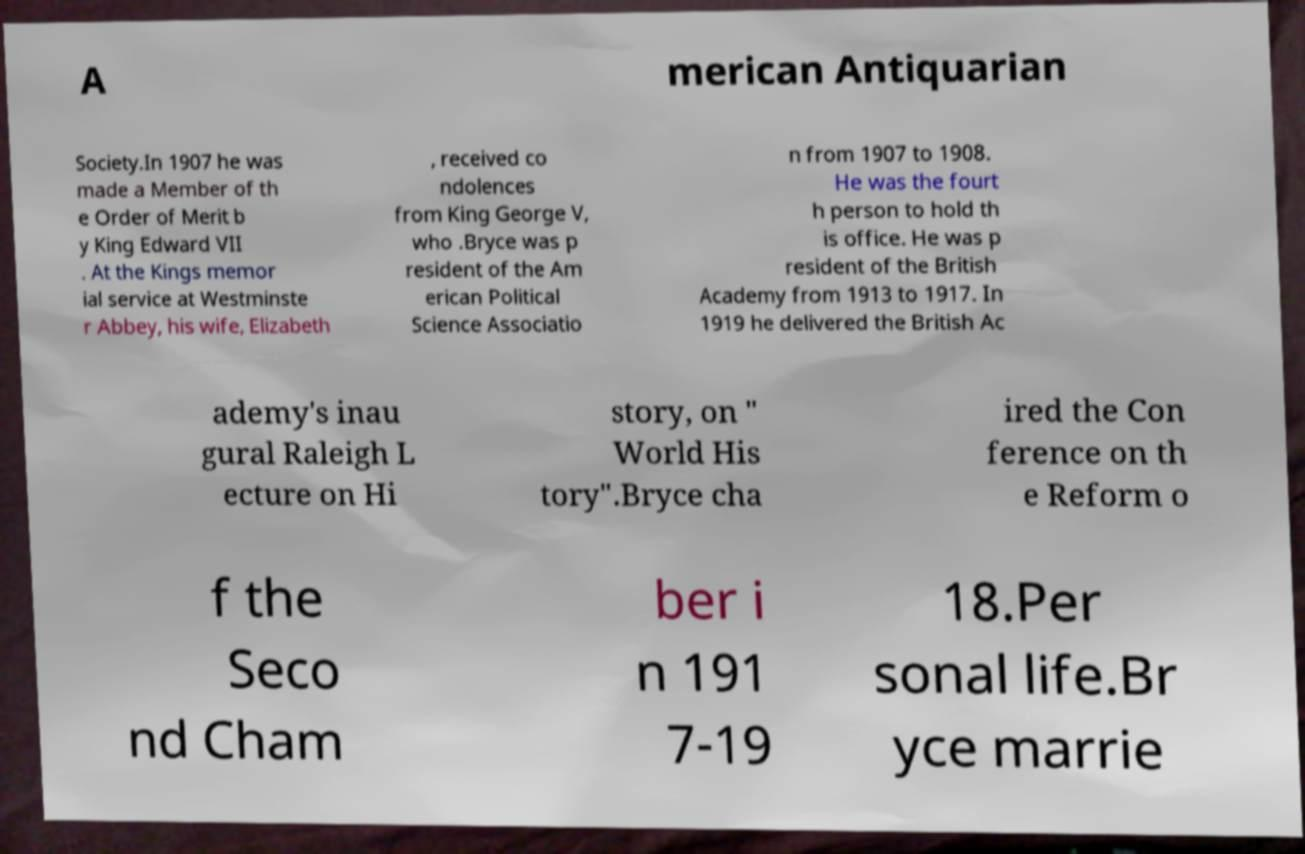Could you extract and type out the text from this image? A merican Antiquarian Society.In 1907 he was made a Member of th e Order of Merit b y King Edward VII . At the Kings memor ial service at Westminste r Abbey, his wife, Elizabeth , received co ndolences from King George V, who .Bryce was p resident of the Am erican Political Science Associatio n from 1907 to 1908. He was the fourt h person to hold th is office. He was p resident of the British Academy from 1913 to 1917. In 1919 he delivered the British Ac ademy's inau gural Raleigh L ecture on Hi story, on " World His tory".Bryce cha ired the Con ference on th e Reform o f the Seco nd Cham ber i n 191 7-19 18.Per sonal life.Br yce marrie 